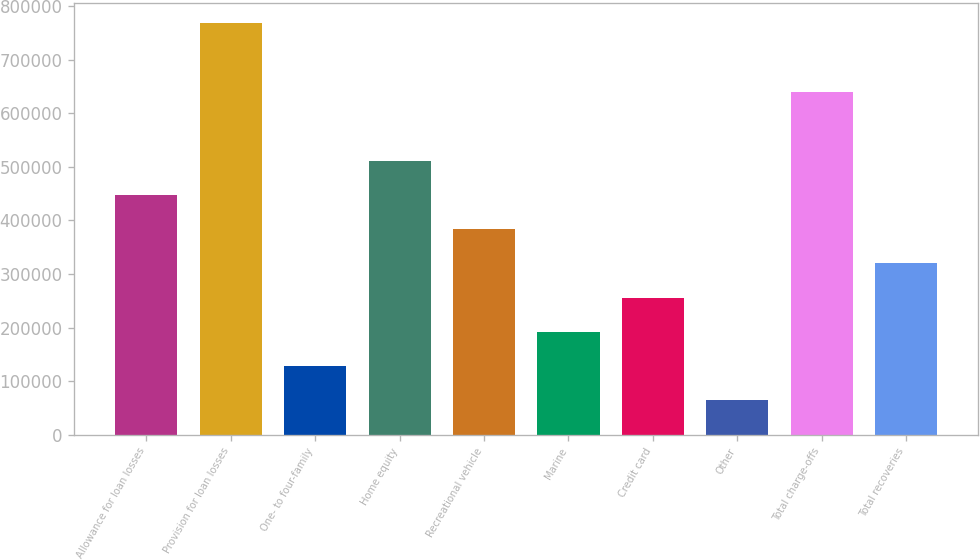Convert chart. <chart><loc_0><loc_0><loc_500><loc_500><bar_chart><fcel>Allowance for loan losses<fcel>Provision for loan losses<fcel>One- to four-family<fcel>Home equity<fcel>Recreational vehicle<fcel>Marine<fcel>Credit card<fcel>Other<fcel>Total charge-offs<fcel>Total recoveries<nl><fcel>448055<fcel>768093<fcel>128016<fcel>512063<fcel>384047<fcel>192024<fcel>256032<fcel>64008.4<fcel>640078<fcel>320039<nl></chart> 